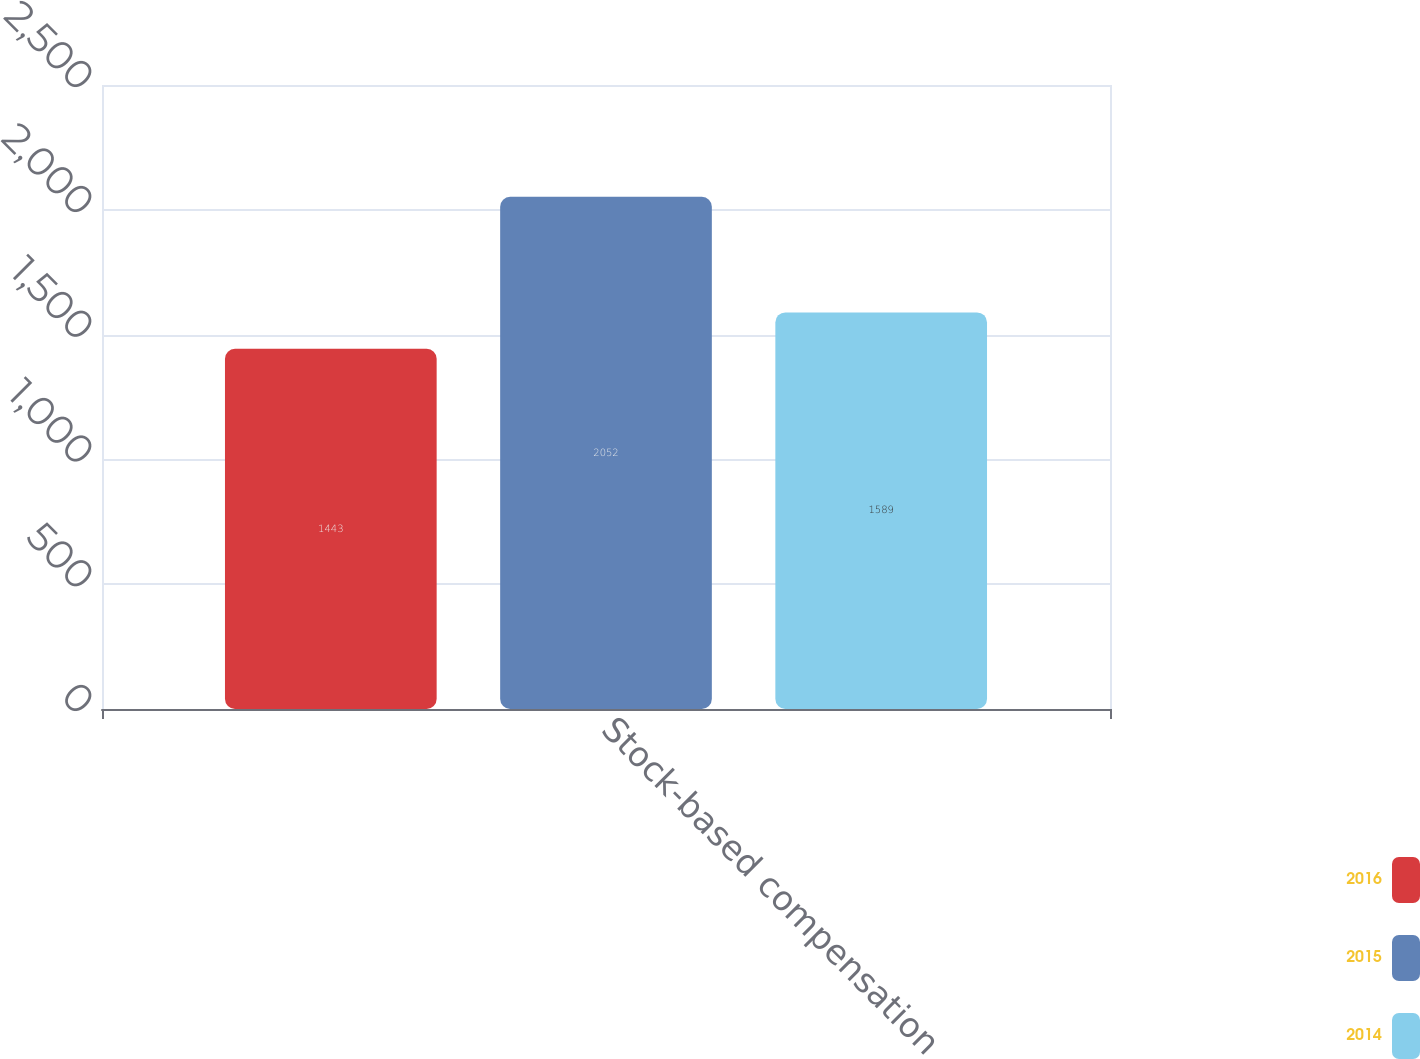Convert chart. <chart><loc_0><loc_0><loc_500><loc_500><stacked_bar_chart><ecel><fcel>Stock-based compensation<nl><fcel>2016<fcel>1443<nl><fcel>2015<fcel>2052<nl><fcel>2014<fcel>1589<nl></chart> 